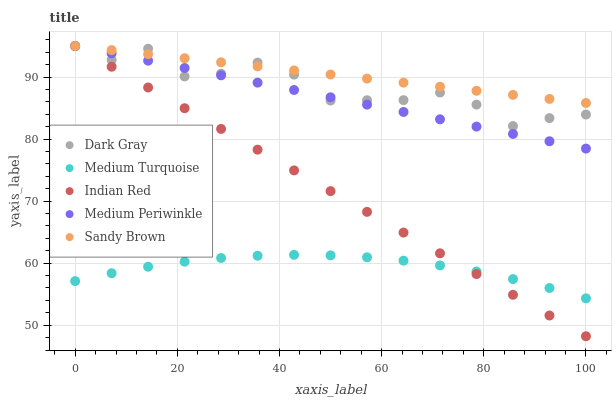Does Medium Turquoise have the minimum area under the curve?
Answer yes or no. Yes. Does Sandy Brown have the maximum area under the curve?
Answer yes or no. Yes. Does Medium Periwinkle have the minimum area under the curve?
Answer yes or no. No. Does Medium Periwinkle have the maximum area under the curve?
Answer yes or no. No. Is Indian Red the smoothest?
Answer yes or no. Yes. Is Dark Gray the roughest?
Answer yes or no. Yes. Is Sandy Brown the smoothest?
Answer yes or no. No. Is Sandy Brown the roughest?
Answer yes or no. No. Does Indian Red have the lowest value?
Answer yes or no. Yes. Does Medium Periwinkle have the lowest value?
Answer yes or no. No. Does Indian Red have the highest value?
Answer yes or no. Yes. Does Medium Turquoise have the highest value?
Answer yes or no. No. Is Medium Turquoise less than Medium Periwinkle?
Answer yes or no. Yes. Is Medium Periwinkle greater than Medium Turquoise?
Answer yes or no. Yes. Does Indian Red intersect Dark Gray?
Answer yes or no. Yes. Is Indian Red less than Dark Gray?
Answer yes or no. No. Is Indian Red greater than Dark Gray?
Answer yes or no. No. Does Medium Turquoise intersect Medium Periwinkle?
Answer yes or no. No. 